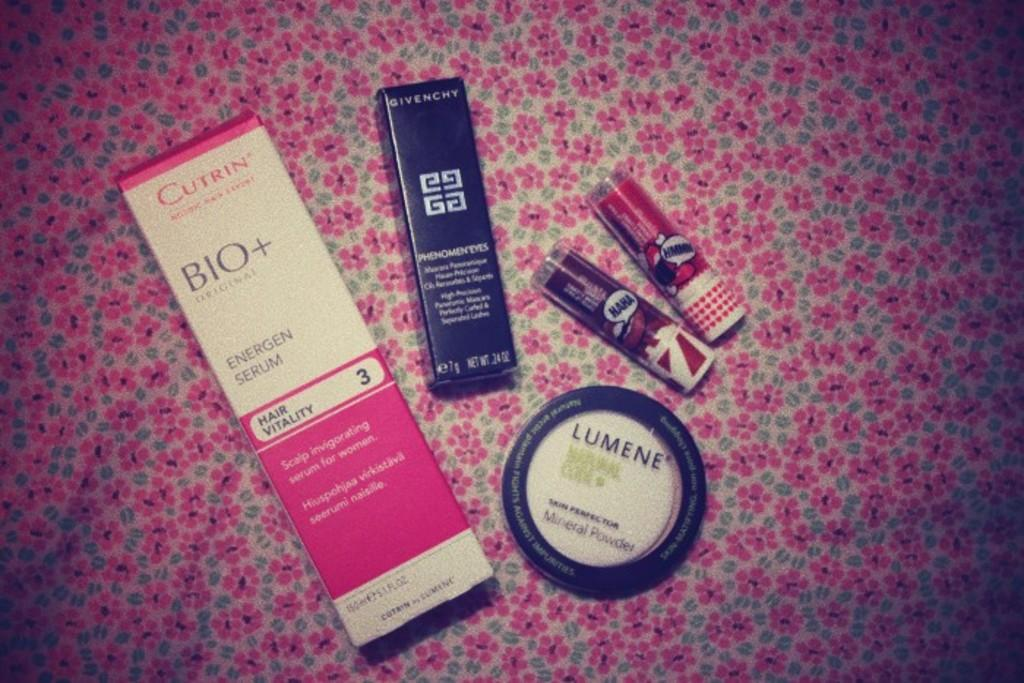Provide a one-sentence caption for the provided image. Some lumene powder and some other face products. 